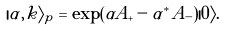<formula> <loc_0><loc_0><loc_500><loc_500>| \alpha , k \rangle _ { p } = \exp ( \alpha A _ { + } - \alpha ^ { * } A _ { - } ) | 0 \rangle .</formula> 